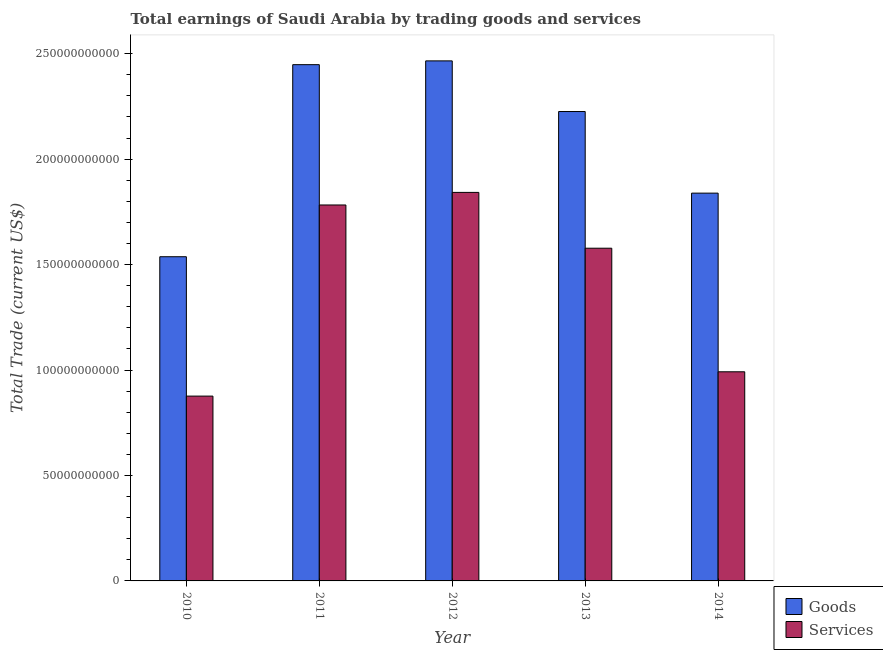How many different coloured bars are there?
Provide a short and direct response. 2. How many groups of bars are there?
Keep it short and to the point. 5. Are the number of bars per tick equal to the number of legend labels?
Your answer should be compact. Yes. Are the number of bars on each tick of the X-axis equal?
Your response must be concise. Yes. How many bars are there on the 3rd tick from the left?
Provide a short and direct response. 2. What is the amount earned by trading services in 2012?
Ensure brevity in your answer.  1.84e+11. Across all years, what is the maximum amount earned by trading services?
Give a very brief answer. 1.84e+11. Across all years, what is the minimum amount earned by trading goods?
Ensure brevity in your answer.  1.54e+11. In which year was the amount earned by trading goods maximum?
Your response must be concise. 2012. In which year was the amount earned by trading services minimum?
Make the answer very short. 2010. What is the total amount earned by trading goods in the graph?
Offer a terse response. 1.05e+12. What is the difference between the amount earned by trading goods in 2011 and that in 2013?
Ensure brevity in your answer.  2.22e+1. What is the difference between the amount earned by trading goods in 2012 and the amount earned by trading services in 2011?
Provide a succinct answer. 1.80e+09. What is the average amount earned by trading services per year?
Offer a very short reply. 1.41e+11. In the year 2014, what is the difference between the amount earned by trading goods and amount earned by trading services?
Keep it short and to the point. 0. In how many years, is the amount earned by trading services greater than 150000000000 US$?
Keep it short and to the point. 3. What is the ratio of the amount earned by trading services in 2011 to that in 2012?
Keep it short and to the point. 0.97. Is the amount earned by trading services in 2012 less than that in 2013?
Your response must be concise. No. What is the difference between the highest and the second highest amount earned by trading goods?
Provide a succinct answer. 1.80e+09. What is the difference between the highest and the lowest amount earned by trading goods?
Offer a terse response. 9.29e+1. In how many years, is the amount earned by trading services greater than the average amount earned by trading services taken over all years?
Provide a succinct answer. 3. What does the 2nd bar from the left in 2010 represents?
Ensure brevity in your answer.  Services. What does the 2nd bar from the right in 2011 represents?
Your response must be concise. Goods. How many bars are there?
Keep it short and to the point. 10. Are all the bars in the graph horizontal?
Offer a terse response. No. Are the values on the major ticks of Y-axis written in scientific E-notation?
Your response must be concise. No. Where does the legend appear in the graph?
Your response must be concise. Bottom right. How are the legend labels stacked?
Offer a terse response. Vertical. What is the title of the graph?
Keep it short and to the point. Total earnings of Saudi Arabia by trading goods and services. Does "Under five" appear as one of the legend labels in the graph?
Provide a succinct answer. No. What is the label or title of the Y-axis?
Offer a very short reply. Total Trade (current US$). What is the Total Trade (current US$) of Goods in 2010?
Offer a very short reply. 1.54e+11. What is the Total Trade (current US$) in Services in 2010?
Keep it short and to the point. 8.76e+1. What is the Total Trade (current US$) in Goods in 2011?
Offer a terse response. 2.45e+11. What is the Total Trade (current US$) in Services in 2011?
Your answer should be very brief. 1.78e+11. What is the Total Trade (current US$) in Goods in 2012?
Keep it short and to the point. 2.47e+11. What is the Total Trade (current US$) of Services in 2012?
Your answer should be compact. 1.84e+11. What is the Total Trade (current US$) in Goods in 2013?
Offer a very short reply. 2.23e+11. What is the Total Trade (current US$) in Services in 2013?
Your answer should be very brief. 1.58e+11. What is the Total Trade (current US$) of Goods in 2014?
Give a very brief answer. 1.84e+11. What is the Total Trade (current US$) of Services in 2014?
Offer a terse response. 9.92e+1. Across all years, what is the maximum Total Trade (current US$) in Goods?
Keep it short and to the point. 2.47e+11. Across all years, what is the maximum Total Trade (current US$) in Services?
Offer a very short reply. 1.84e+11. Across all years, what is the minimum Total Trade (current US$) in Goods?
Your answer should be very brief. 1.54e+11. Across all years, what is the minimum Total Trade (current US$) of Services?
Ensure brevity in your answer.  8.76e+1. What is the total Total Trade (current US$) of Goods in the graph?
Offer a terse response. 1.05e+12. What is the total Total Trade (current US$) in Services in the graph?
Keep it short and to the point. 7.07e+11. What is the difference between the Total Trade (current US$) of Goods in 2010 and that in 2011?
Provide a succinct answer. -9.11e+1. What is the difference between the Total Trade (current US$) in Services in 2010 and that in 2011?
Make the answer very short. -9.06e+1. What is the difference between the Total Trade (current US$) of Goods in 2010 and that in 2012?
Your answer should be compact. -9.29e+1. What is the difference between the Total Trade (current US$) in Services in 2010 and that in 2012?
Give a very brief answer. -9.66e+1. What is the difference between the Total Trade (current US$) of Goods in 2010 and that in 2013?
Your response must be concise. -6.88e+1. What is the difference between the Total Trade (current US$) in Services in 2010 and that in 2013?
Your answer should be compact. -7.01e+1. What is the difference between the Total Trade (current US$) in Goods in 2010 and that in 2014?
Your answer should be compact. -3.02e+1. What is the difference between the Total Trade (current US$) in Services in 2010 and that in 2014?
Give a very brief answer. -1.15e+1. What is the difference between the Total Trade (current US$) in Goods in 2011 and that in 2012?
Keep it short and to the point. -1.80e+09. What is the difference between the Total Trade (current US$) of Services in 2011 and that in 2012?
Your answer should be compact. -5.97e+09. What is the difference between the Total Trade (current US$) of Goods in 2011 and that in 2013?
Offer a very short reply. 2.22e+1. What is the difference between the Total Trade (current US$) in Services in 2011 and that in 2013?
Ensure brevity in your answer.  2.05e+1. What is the difference between the Total Trade (current US$) in Goods in 2011 and that in 2014?
Ensure brevity in your answer.  6.09e+1. What is the difference between the Total Trade (current US$) in Services in 2011 and that in 2014?
Offer a terse response. 7.91e+1. What is the difference between the Total Trade (current US$) of Goods in 2012 and that in 2013?
Provide a succinct answer. 2.40e+1. What is the difference between the Total Trade (current US$) in Services in 2012 and that in 2013?
Keep it short and to the point. 2.65e+1. What is the difference between the Total Trade (current US$) of Goods in 2012 and that in 2014?
Make the answer very short. 6.27e+1. What is the difference between the Total Trade (current US$) of Services in 2012 and that in 2014?
Your answer should be very brief. 8.51e+1. What is the difference between the Total Trade (current US$) in Goods in 2013 and that in 2014?
Give a very brief answer. 3.87e+1. What is the difference between the Total Trade (current US$) in Services in 2013 and that in 2014?
Make the answer very short. 5.86e+1. What is the difference between the Total Trade (current US$) in Goods in 2010 and the Total Trade (current US$) in Services in 2011?
Your answer should be compact. -2.45e+1. What is the difference between the Total Trade (current US$) of Goods in 2010 and the Total Trade (current US$) of Services in 2012?
Your answer should be compact. -3.05e+1. What is the difference between the Total Trade (current US$) of Goods in 2010 and the Total Trade (current US$) of Services in 2013?
Give a very brief answer. -4.04e+09. What is the difference between the Total Trade (current US$) in Goods in 2010 and the Total Trade (current US$) in Services in 2014?
Make the answer very short. 5.46e+1. What is the difference between the Total Trade (current US$) of Goods in 2011 and the Total Trade (current US$) of Services in 2012?
Offer a terse response. 6.06e+1. What is the difference between the Total Trade (current US$) in Goods in 2011 and the Total Trade (current US$) in Services in 2013?
Ensure brevity in your answer.  8.70e+1. What is the difference between the Total Trade (current US$) in Goods in 2011 and the Total Trade (current US$) in Services in 2014?
Make the answer very short. 1.46e+11. What is the difference between the Total Trade (current US$) of Goods in 2012 and the Total Trade (current US$) of Services in 2013?
Your answer should be very brief. 8.88e+1. What is the difference between the Total Trade (current US$) of Goods in 2012 and the Total Trade (current US$) of Services in 2014?
Your answer should be very brief. 1.47e+11. What is the difference between the Total Trade (current US$) in Goods in 2013 and the Total Trade (current US$) in Services in 2014?
Your answer should be compact. 1.23e+11. What is the average Total Trade (current US$) of Goods per year?
Give a very brief answer. 2.10e+11. What is the average Total Trade (current US$) in Services per year?
Your answer should be compact. 1.41e+11. In the year 2010, what is the difference between the Total Trade (current US$) of Goods and Total Trade (current US$) of Services?
Your answer should be very brief. 6.61e+1. In the year 2011, what is the difference between the Total Trade (current US$) of Goods and Total Trade (current US$) of Services?
Your answer should be compact. 6.65e+1. In the year 2012, what is the difference between the Total Trade (current US$) in Goods and Total Trade (current US$) in Services?
Your response must be concise. 6.24e+1. In the year 2013, what is the difference between the Total Trade (current US$) in Goods and Total Trade (current US$) in Services?
Your answer should be compact. 6.48e+1. In the year 2014, what is the difference between the Total Trade (current US$) in Goods and Total Trade (current US$) in Services?
Your response must be concise. 8.47e+1. What is the ratio of the Total Trade (current US$) in Goods in 2010 to that in 2011?
Your response must be concise. 0.63. What is the ratio of the Total Trade (current US$) in Services in 2010 to that in 2011?
Ensure brevity in your answer.  0.49. What is the ratio of the Total Trade (current US$) of Goods in 2010 to that in 2012?
Offer a terse response. 0.62. What is the ratio of the Total Trade (current US$) of Services in 2010 to that in 2012?
Your response must be concise. 0.48. What is the ratio of the Total Trade (current US$) of Goods in 2010 to that in 2013?
Keep it short and to the point. 0.69. What is the ratio of the Total Trade (current US$) in Services in 2010 to that in 2013?
Your answer should be very brief. 0.56. What is the ratio of the Total Trade (current US$) of Goods in 2010 to that in 2014?
Your answer should be very brief. 0.84. What is the ratio of the Total Trade (current US$) of Services in 2010 to that in 2014?
Provide a succinct answer. 0.88. What is the ratio of the Total Trade (current US$) of Goods in 2011 to that in 2012?
Offer a very short reply. 0.99. What is the ratio of the Total Trade (current US$) in Services in 2011 to that in 2012?
Provide a short and direct response. 0.97. What is the ratio of the Total Trade (current US$) in Goods in 2011 to that in 2013?
Provide a succinct answer. 1.1. What is the ratio of the Total Trade (current US$) of Services in 2011 to that in 2013?
Keep it short and to the point. 1.13. What is the ratio of the Total Trade (current US$) of Goods in 2011 to that in 2014?
Offer a very short reply. 1.33. What is the ratio of the Total Trade (current US$) in Services in 2011 to that in 2014?
Keep it short and to the point. 1.8. What is the ratio of the Total Trade (current US$) in Goods in 2012 to that in 2013?
Offer a very short reply. 1.11. What is the ratio of the Total Trade (current US$) of Services in 2012 to that in 2013?
Offer a terse response. 1.17. What is the ratio of the Total Trade (current US$) of Goods in 2012 to that in 2014?
Your response must be concise. 1.34. What is the ratio of the Total Trade (current US$) of Services in 2012 to that in 2014?
Your response must be concise. 1.86. What is the ratio of the Total Trade (current US$) of Goods in 2013 to that in 2014?
Ensure brevity in your answer.  1.21. What is the ratio of the Total Trade (current US$) of Services in 2013 to that in 2014?
Provide a short and direct response. 1.59. What is the difference between the highest and the second highest Total Trade (current US$) in Goods?
Offer a terse response. 1.80e+09. What is the difference between the highest and the second highest Total Trade (current US$) in Services?
Give a very brief answer. 5.97e+09. What is the difference between the highest and the lowest Total Trade (current US$) in Goods?
Provide a short and direct response. 9.29e+1. What is the difference between the highest and the lowest Total Trade (current US$) in Services?
Ensure brevity in your answer.  9.66e+1. 